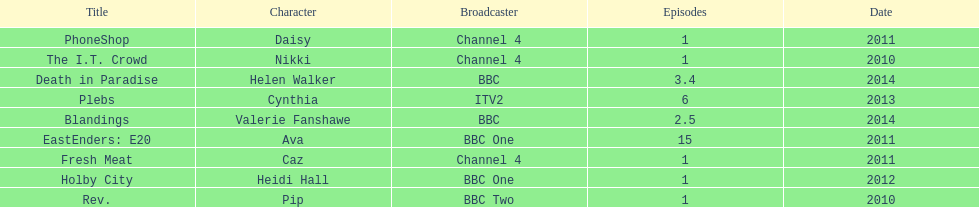Blandings and death in paradise both aired on which broadcaster? BBC. 